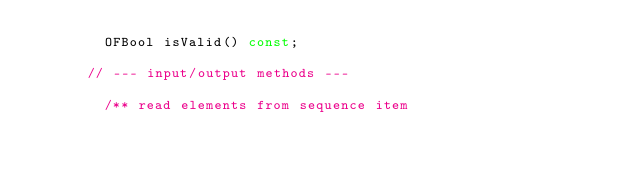Convert code to text. <code><loc_0><loc_0><loc_500><loc_500><_C_>        OFBool isValid() const;

      // --- input/output methods ---

        /** read elements from sequence item</code> 